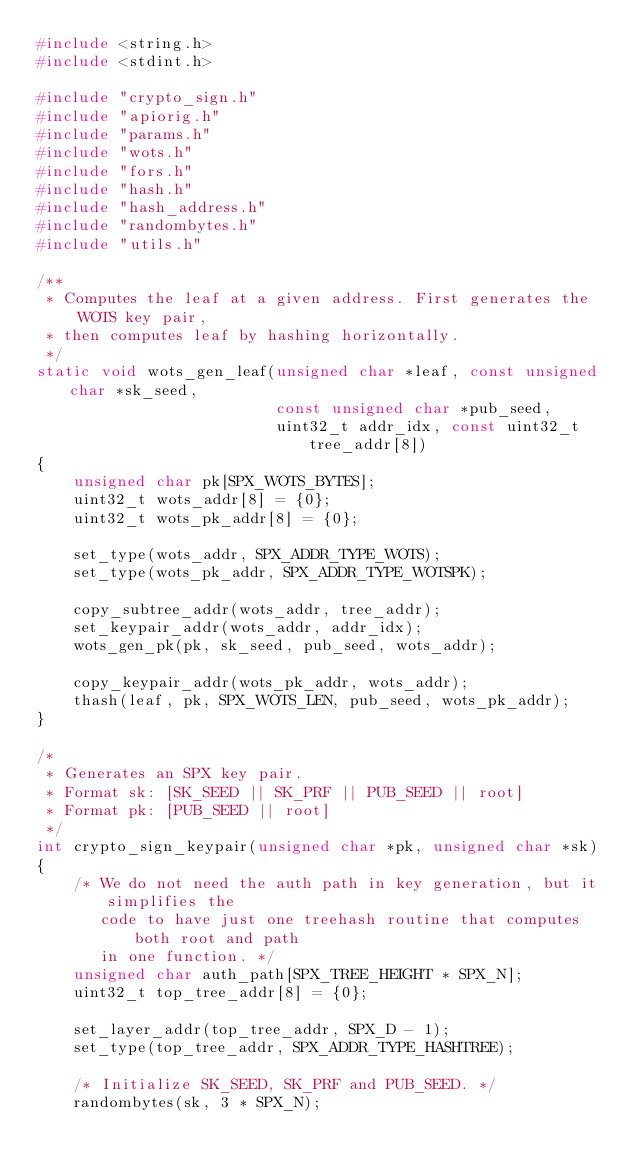Convert code to text. <code><loc_0><loc_0><loc_500><loc_500><_C_>#include <string.h>
#include <stdint.h>

#include "crypto_sign.h"
#include "apiorig.h"
#include "params.h"
#include "wots.h"
#include "fors.h"
#include "hash.h"
#include "hash_address.h"
#include "randombytes.h"
#include "utils.h"

/**
 * Computes the leaf at a given address. First generates the WOTS key pair,
 * then computes leaf by hashing horizontally.
 */
static void wots_gen_leaf(unsigned char *leaf, const unsigned char *sk_seed,
                          const unsigned char *pub_seed,
                          uint32_t addr_idx, const uint32_t tree_addr[8])
{
    unsigned char pk[SPX_WOTS_BYTES];
    uint32_t wots_addr[8] = {0};
    uint32_t wots_pk_addr[8] = {0};

    set_type(wots_addr, SPX_ADDR_TYPE_WOTS);
    set_type(wots_pk_addr, SPX_ADDR_TYPE_WOTSPK);

    copy_subtree_addr(wots_addr, tree_addr);
    set_keypair_addr(wots_addr, addr_idx);
    wots_gen_pk(pk, sk_seed, pub_seed, wots_addr);

    copy_keypair_addr(wots_pk_addr, wots_addr);
    thash(leaf, pk, SPX_WOTS_LEN, pub_seed, wots_pk_addr);
}

/*
 * Generates an SPX key pair.
 * Format sk: [SK_SEED || SK_PRF || PUB_SEED || root]
 * Format pk: [PUB_SEED || root]
 */
int crypto_sign_keypair(unsigned char *pk, unsigned char *sk)
{
    /* We do not need the auth path in key generation, but it simplifies the
       code to have just one treehash routine that computes both root and path
       in one function. */
    unsigned char auth_path[SPX_TREE_HEIGHT * SPX_N];
    uint32_t top_tree_addr[8] = {0};

    set_layer_addr(top_tree_addr, SPX_D - 1);
    set_type(top_tree_addr, SPX_ADDR_TYPE_HASHTREE);

    /* Initialize SK_SEED, SK_PRF and PUB_SEED. */
    randombytes(sk, 3 * SPX_N);
</code> 